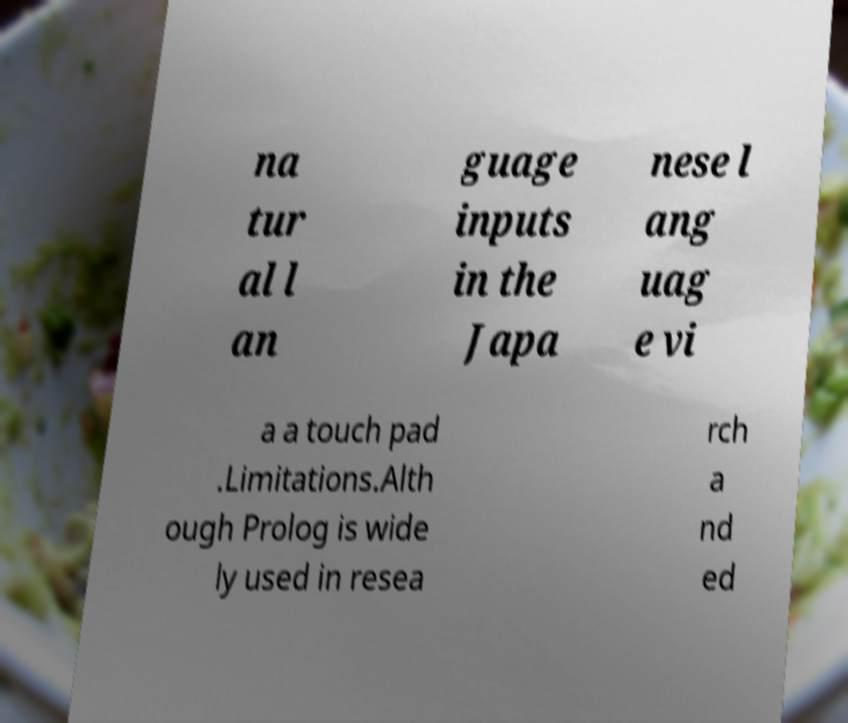I need the written content from this picture converted into text. Can you do that? na tur al l an guage inputs in the Japa nese l ang uag e vi a a touch pad .Limitations.Alth ough Prolog is wide ly used in resea rch a nd ed 